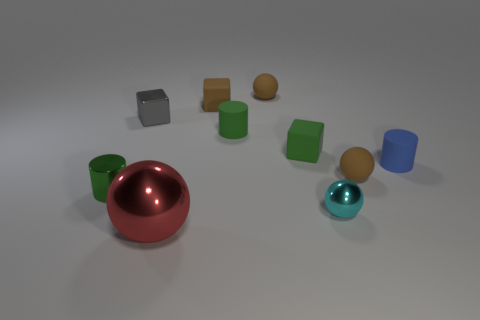There is a tiny brown matte thing right of the tiny rubber sphere to the left of the shiny thing on the right side of the big metal ball; what is its shape?
Offer a terse response. Sphere. The large thing has what shape?
Keep it short and to the point. Sphere. The small block that is left of the brown rubber cube is what color?
Provide a short and direct response. Gray. There is a metallic sphere right of the green matte cube; does it have the same size as the red thing?
Offer a terse response. No. There is another matte thing that is the same shape as the small blue object; what size is it?
Keep it short and to the point. Small. Are there any other things that have the same size as the red sphere?
Keep it short and to the point. No. Is the shape of the large red metal object the same as the tiny cyan metal thing?
Offer a terse response. Yes. Is the number of tiny matte cylinders in front of the tiny green rubber block less than the number of tiny rubber blocks that are right of the large object?
Ensure brevity in your answer.  Yes. There is a blue cylinder; how many tiny objects are on the right side of it?
Your response must be concise. 0. There is a brown rubber thing in front of the small blue matte cylinder; is its shape the same as the tiny metallic thing behind the small blue rubber thing?
Keep it short and to the point. No. 